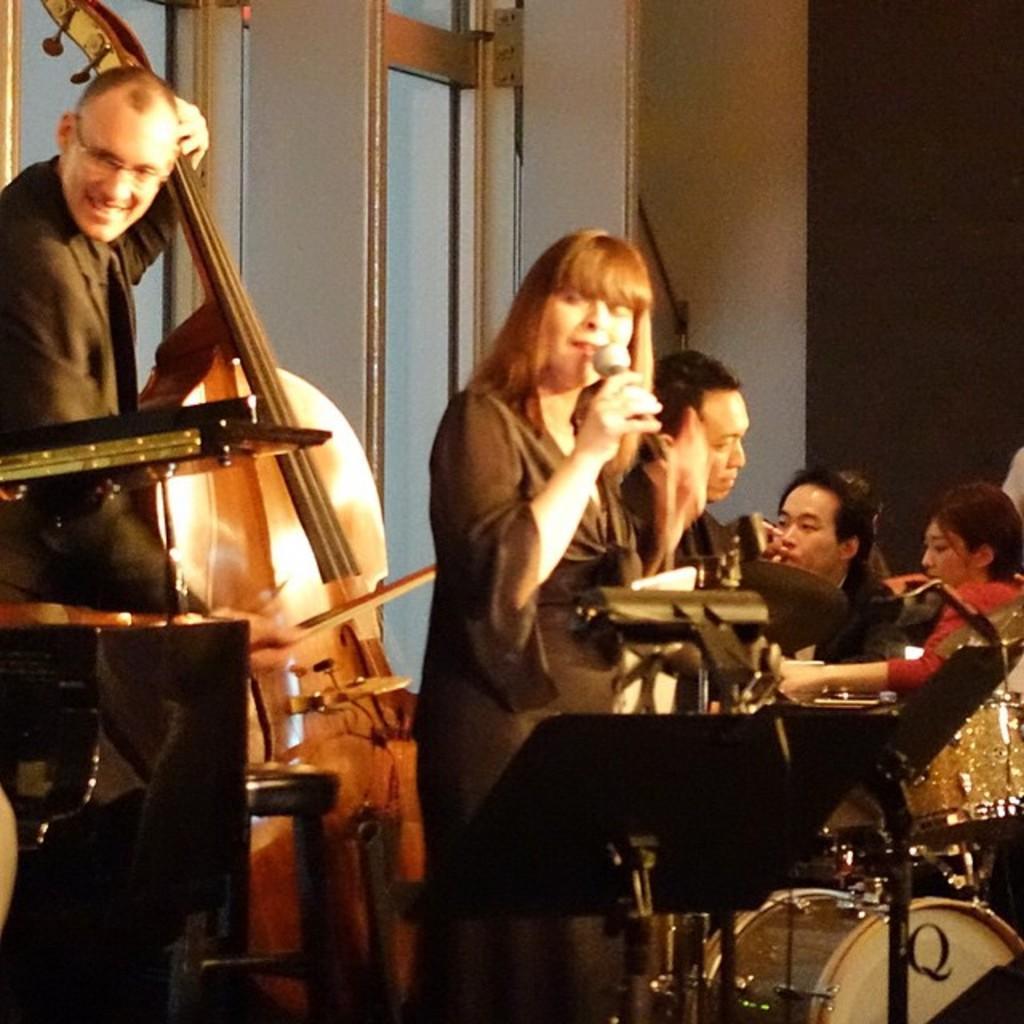Describe this image in one or two sentences. In this image, we can see some people sitting, there is a man and a woman standing. There are some musical instruments. We can see the wall and windows. 